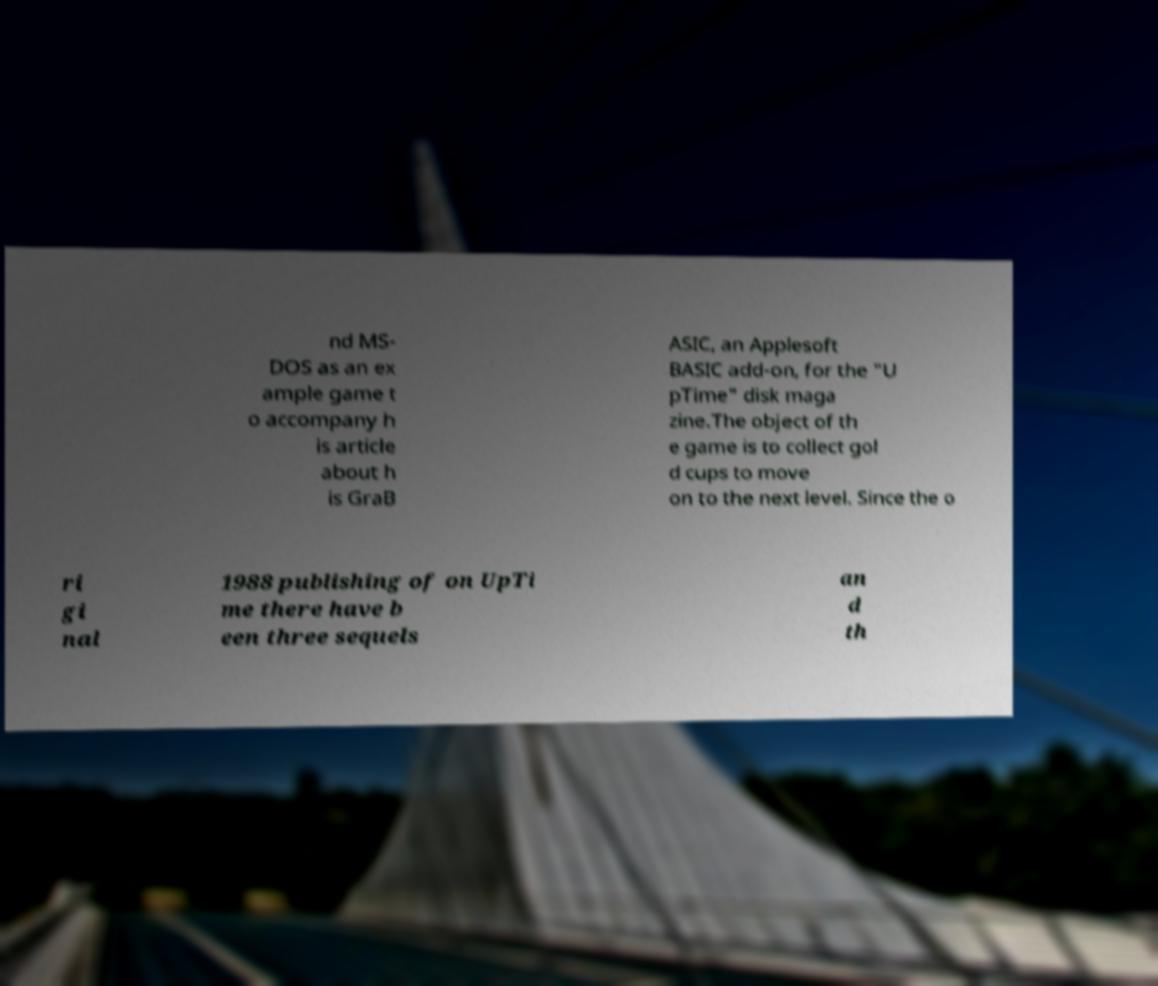Please read and relay the text visible in this image. What does it say? nd MS- DOS as an ex ample game t o accompany h is article about h is GraB ASIC, an Applesoft BASIC add-on, for the "U pTime" disk maga zine.The object of th e game is to collect gol d cups to move on to the next level. Since the o ri gi nal 1988 publishing of on UpTi me there have b een three sequels an d th 